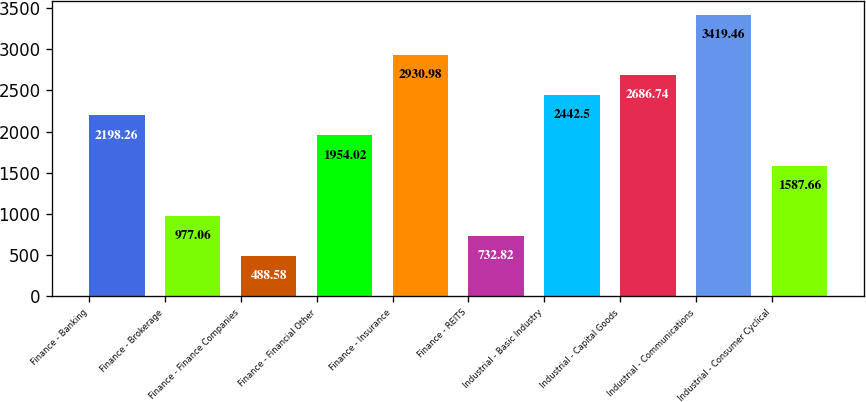<chart> <loc_0><loc_0><loc_500><loc_500><bar_chart><fcel>Finance - Banking<fcel>Finance - Brokerage<fcel>Finance - Finance Companies<fcel>Finance - Financial Other<fcel>Finance - Insurance<fcel>Finance - REITS<fcel>Industrial - Basic Industry<fcel>Industrial - Capital Goods<fcel>Industrial - Communications<fcel>Industrial - Consumer Cyclical<nl><fcel>2198.26<fcel>977.06<fcel>488.58<fcel>1954.02<fcel>2930.98<fcel>732.82<fcel>2442.5<fcel>2686.74<fcel>3419.46<fcel>1587.66<nl></chart> 